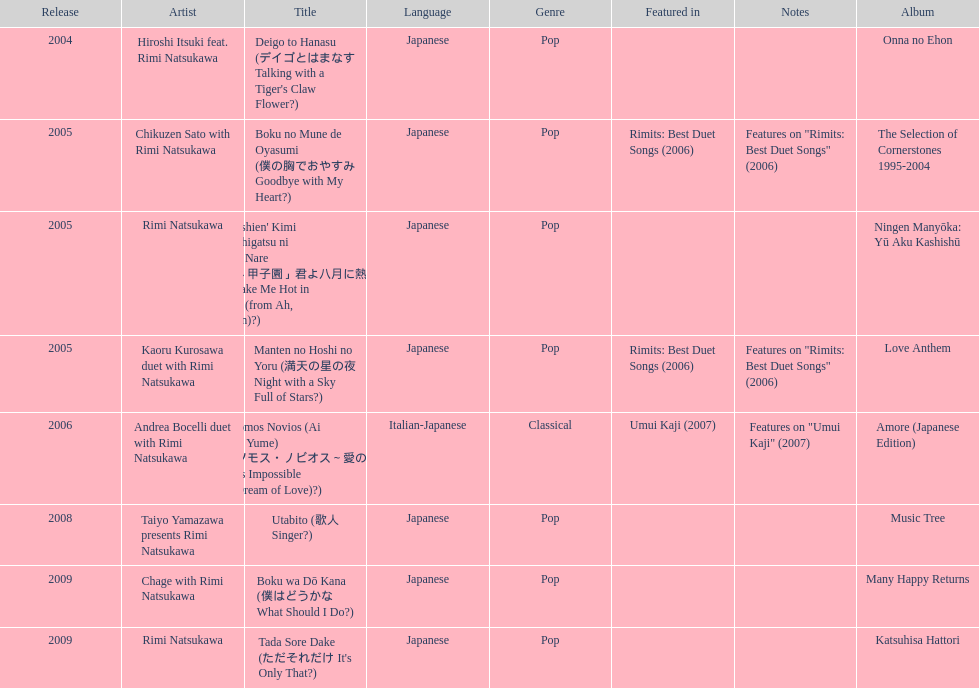Which was released earlier, deigo to hanasu or utabito? Deigo to Hanasu. 